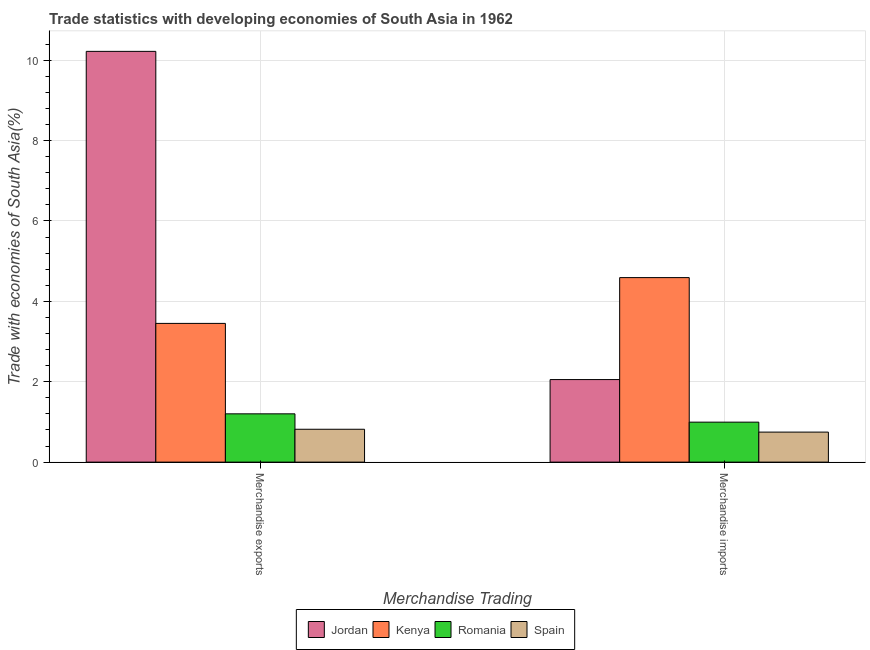How many groups of bars are there?
Ensure brevity in your answer.  2. How many bars are there on the 2nd tick from the left?
Provide a short and direct response. 4. What is the merchandise imports in Romania?
Provide a succinct answer. 0.99. Across all countries, what is the maximum merchandise exports?
Provide a succinct answer. 10.22. Across all countries, what is the minimum merchandise imports?
Give a very brief answer. 0.75. In which country was the merchandise exports maximum?
Offer a very short reply. Jordan. What is the total merchandise exports in the graph?
Offer a terse response. 15.69. What is the difference between the merchandise imports in Spain and that in Romania?
Your answer should be compact. -0.25. What is the difference between the merchandise exports in Kenya and the merchandise imports in Spain?
Offer a terse response. 2.7. What is the average merchandise imports per country?
Offer a very short reply. 2.1. What is the difference between the merchandise exports and merchandise imports in Romania?
Provide a short and direct response. 0.21. In how many countries, is the merchandise exports greater than 5.2 %?
Offer a very short reply. 1. What is the ratio of the merchandise imports in Kenya to that in Spain?
Your answer should be very brief. 6.14. Is the merchandise imports in Romania less than that in Kenya?
Give a very brief answer. Yes. In how many countries, is the merchandise imports greater than the average merchandise imports taken over all countries?
Keep it short and to the point. 1. What does the 4th bar from the left in Merchandise imports represents?
Provide a succinct answer. Spain. How many bars are there?
Offer a terse response. 8. What is the difference between two consecutive major ticks on the Y-axis?
Your response must be concise. 2. Does the graph contain any zero values?
Ensure brevity in your answer.  No. How many legend labels are there?
Make the answer very short. 4. What is the title of the graph?
Give a very brief answer. Trade statistics with developing economies of South Asia in 1962. Does "Small states" appear as one of the legend labels in the graph?
Ensure brevity in your answer.  No. What is the label or title of the X-axis?
Provide a short and direct response. Merchandise Trading. What is the label or title of the Y-axis?
Keep it short and to the point. Trade with economies of South Asia(%). What is the Trade with economies of South Asia(%) of Jordan in Merchandise exports?
Give a very brief answer. 10.22. What is the Trade with economies of South Asia(%) in Kenya in Merchandise exports?
Provide a short and direct response. 3.45. What is the Trade with economies of South Asia(%) of Romania in Merchandise exports?
Your answer should be very brief. 1.2. What is the Trade with economies of South Asia(%) of Spain in Merchandise exports?
Keep it short and to the point. 0.82. What is the Trade with economies of South Asia(%) of Jordan in Merchandise imports?
Provide a short and direct response. 2.05. What is the Trade with economies of South Asia(%) of Kenya in Merchandise imports?
Offer a very short reply. 4.59. What is the Trade with economies of South Asia(%) of Romania in Merchandise imports?
Your answer should be very brief. 0.99. What is the Trade with economies of South Asia(%) in Spain in Merchandise imports?
Keep it short and to the point. 0.75. Across all Merchandise Trading, what is the maximum Trade with economies of South Asia(%) in Jordan?
Give a very brief answer. 10.22. Across all Merchandise Trading, what is the maximum Trade with economies of South Asia(%) in Kenya?
Your answer should be compact. 4.59. Across all Merchandise Trading, what is the maximum Trade with economies of South Asia(%) in Romania?
Your answer should be very brief. 1.2. Across all Merchandise Trading, what is the maximum Trade with economies of South Asia(%) of Spain?
Give a very brief answer. 0.82. Across all Merchandise Trading, what is the minimum Trade with economies of South Asia(%) of Jordan?
Your answer should be compact. 2.05. Across all Merchandise Trading, what is the minimum Trade with economies of South Asia(%) in Kenya?
Offer a terse response. 3.45. Across all Merchandise Trading, what is the minimum Trade with economies of South Asia(%) in Romania?
Your response must be concise. 0.99. Across all Merchandise Trading, what is the minimum Trade with economies of South Asia(%) in Spain?
Provide a short and direct response. 0.75. What is the total Trade with economies of South Asia(%) of Jordan in the graph?
Your response must be concise. 12.27. What is the total Trade with economies of South Asia(%) of Kenya in the graph?
Keep it short and to the point. 8.04. What is the total Trade with economies of South Asia(%) in Romania in the graph?
Give a very brief answer. 2.2. What is the total Trade with economies of South Asia(%) in Spain in the graph?
Ensure brevity in your answer.  1.56. What is the difference between the Trade with economies of South Asia(%) in Jordan in Merchandise exports and that in Merchandise imports?
Your answer should be very brief. 8.17. What is the difference between the Trade with economies of South Asia(%) in Kenya in Merchandise exports and that in Merchandise imports?
Provide a short and direct response. -1.14. What is the difference between the Trade with economies of South Asia(%) of Romania in Merchandise exports and that in Merchandise imports?
Give a very brief answer. 0.21. What is the difference between the Trade with economies of South Asia(%) in Spain in Merchandise exports and that in Merchandise imports?
Ensure brevity in your answer.  0.07. What is the difference between the Trade with economies of South Asia(%) in Jordan in Merchandise exports and the Trade with economies of South Asia(%) in Kenya in Merchandise imports?
Offer a very short reply. 5.63. What is the difference between the Trade with economies of South Asia(%) in Jordan in Merchandise exports and the Trade with economies of South Asia(%) in Romania in Merchandise imports?
Your response must be concise. 9.22. What is the difference between the Trade with economies of South Asia(%) of Jordan in Merchandise exports and the Trade with economies of South Asia(%) of Spain in Merchandise imports?
Your answer should be very brief. 9.47. What is the difference between the Trade with economies of South Asia(%) in Kenya in Merchandise exports and the Trade with economies of South Asia(%) in Romania in Merchandise imports?
Keep it short and to the point. 2.46. What is the difference between the Trade with economies of South Asia(%) of Kenya in Merchandise exports and the Trade with economies of South Asia(%) of Spain in Merchandise imports?
Make the answer very short. 2.7. What is the difference between the Trade with economies of South Asia(%) in Romania in Merchandise exports and the Trade with economies of South Asia(%) in Spain in Merchandise imports?
Provide a short and direct response. 0.45. What is the average Trade with economies of South Asia(%) in Jordan per Merchandise Trading?
Your response must be concise. 6.14. What is the average Trade with economies of South Asia(%) in Kenya per Merchandise Trading?
Your response must be concise. 4.02. What is the average Trade with economies of South Asia(%) of Romania per Merchandise Trading?
Make the answer very short. 1.1. What is the average Trade with economies of South Asia(%) of Spain per Merchandise Trading?
Your response must be concise. 0.78. What is the difference between the Trade with economies of South Asia(%) in Jordan and Trade with economies of South Asia(%) in Kenya in Merchandise exports?
Ensure brevity in your answer.  6.77. What is the difference between the Trade with economies of South Asia(%) in Jordan and Trade with economies of South Asia(%) in Romania in Merchandise exports?
Provide a succinct answer. 9.02. What is the difference between the Trade with economies of South Asia(%) of Jordan and Trade with economies of South Asia(%) of Spain in Merchandise exports?
Ensure brevity in your answer.  9.4. What is the difference between the Trade with economies of South Asia(%) in Kenya and Trade with economies of South Asia(%) in Romania in Merchandise exports?
Give a very brief answer. 2.25. What is the difference between the Trade with economies of South Asia(%) in Kenya and Trade with economies of South Asia(%) in Spain in Merchandise exports?
Offer a terse response. 2.63. What is the difference between the Trade with economies of South Asia(%) in Romania and Trade with economies of South Asia(%) in Spain in Merchandise exports?
Keep it short and to the point. 0.38. What is the difference between the Trade with economies of South Asia(%) of Jordan and Trade with economies of South Asia(%) of Kenya in Merchandise imports?
Provide a succinct answer. -2.54. What is the difference between the Trade with economies of South Asia(%) of Jordan and Trade with economies of South Asia(%) of Romania in Merchandise imports?
Your answer should be very brief. 1.06. What is the difference between the Trade with economies of South Asia(%) in Jordan and Trade with economies of South Asia(%) in Spain in Merchandise imports?
Offer a very short reply. 1.31. What is the difference between the Trade with economies of South Asia(%) of Kenya and Trade with economies of South Asia(%) of Romania in Merchandise imports?
Your response must be concise. 3.6. What is the difference between the Trade with economies of South Asia(%) of Kenya and Trade with economies of South Asia(%) of Spain in Merchandise imports?
Offer a very short reply. 3.84. What is the difference between the Trade with economies of South Asia(%) in Romania and Trade with economies of South Asia(%) in Spain in Merchandise imports?
Offer a very short reply. 0.25. What is the ratio of the Trade with economies of South Asia(%) of Jordan in Merchandise exports to that in Merchandise imports?
Your answer should be very brief. 4.98. What is the ratio of the Trade with economies of South Asia(%) of Kenya in Merchandise exports to that in Merchandise imports?
Provide a succinct answer. 0.75. What is the ratio of the Trade with economies of South Asia(%) of Romania in Merchandise exports to that in Merchandise imports?
Your answer should be compact. 1.21. What is the ratio of the Trade with economies of South Asia(%) of Spain in Merchandise exports to that in Merchandise imports?
Your response must be concise. 1.09. What is the difference between the highest and the second highest Trade with economies of South Asia(%) of Jordan?
Offer a terse response. 8.17. What is the difference between the highest and the second highest Trade with economies of South Asia(%) of Kenya?
Offer a terse response. 1.14. What is the difference between the highest and the second highest Trade with economies of South Asia(%) in Romania?
Your answer should be compact. 0.21. What is the difference between the highest and the second highest Trade with economies of South Asia(%) in Spain?
Your answer should be compact. 0.07. What is the difference between the highest and the lowest Trade with economies of South Asia(%) of Jordan?
Your answer should be very brief. 8.17. What is the difference between the highest and the lowest Trade with economies of South Asia(%) in Kenya?
Keep it short and to the point. 1.14. What is the difference between the highest and the lowest Trade with economies of South Asia(%) in Romania?
Your response must be concise. 0.21. What is the difference between the highest and the lowest Trade with economies of South Asia(%) in Spain?
Offer a very short reply. 0.07. 